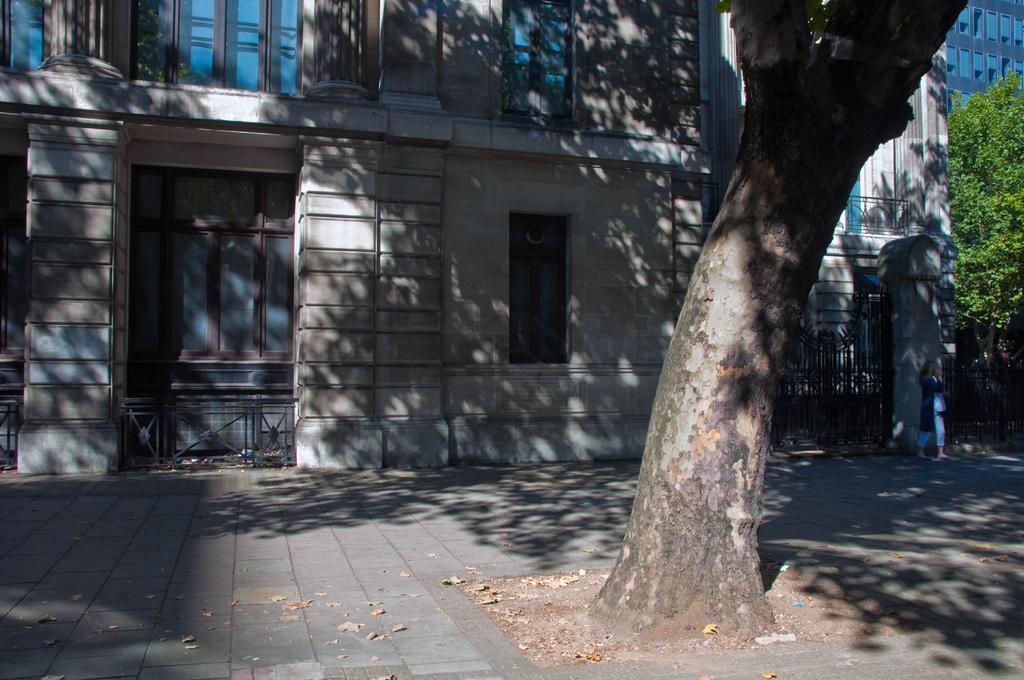What type of structures can be seen in the image? There are buildings in the image. What feature is visible on the buildings? There are windows visible in the image. What type of vegetation is present in the image? There are trees in the image. What type of barrier can be seen in the image? There is fencing in the image. Can you describe the person in the image? There is a person standing in the image. What type of beetle can be seen sailing on the ship in the image? There is no beetle or ship present in the image. What does the person in the image need to complete their task? The image does not provide information about the person's task or what they might need to complete it. 